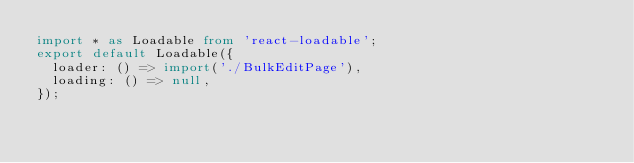Convert code to text. <code><loc_0><loc_0><loc_500><loc_500><_TypeScript_>import * as Loadable from 'react-loadable';
export default Loadable({
  loader: () => import('./BulkEditPage'),
  loading: () => null,
});
</code> 